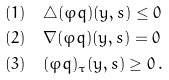Convert formula to latex. <formula><loc_0><loc_0><loc_500><loc_500>& ( 1 ) \quad \triangle ( \varphi q ) ( y , s ) \leq 0 \\ & ( 2 ) \quad \nabla ( \varphi q ) ( y , s ) = 0 \\ & ( 3 ) \quad ( \varphi q ) _ { \tau } ( y , s ) \geq 0 \, .</formula> 